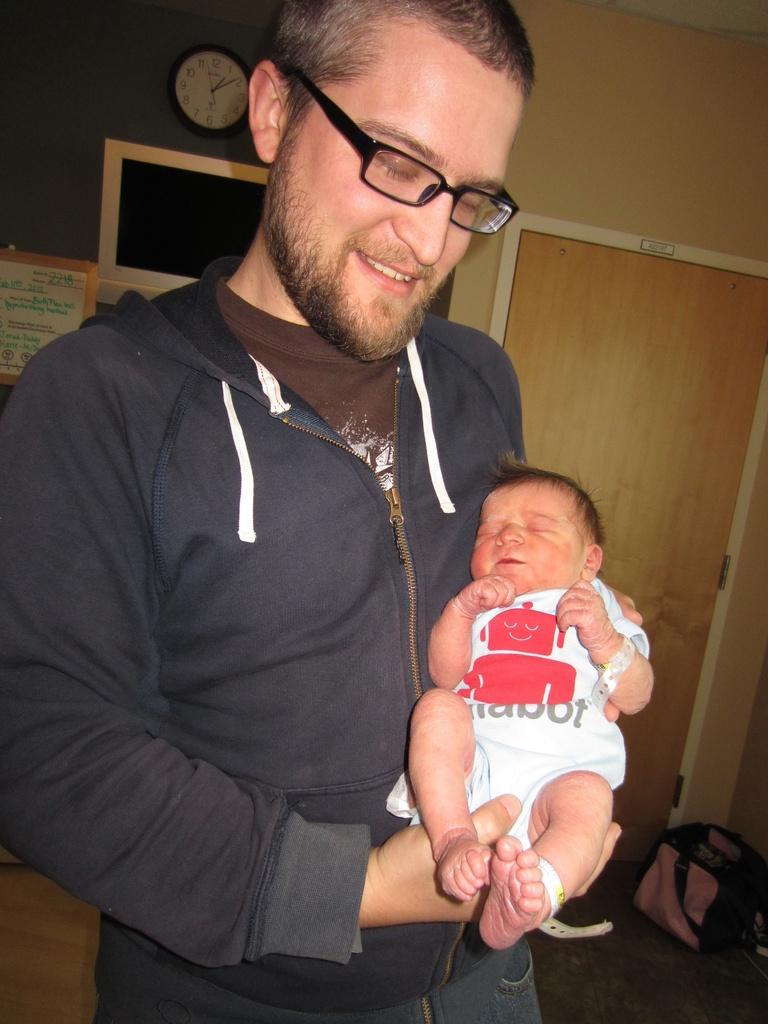Can you describe this image briefly? In the center of the image we can see one person is standing and he is holding one baby. And he is smiling and he is wearing glasses. In the background there is a wall, door, wall clock, banner, bag and a few other objects. On the banner, we can see some text. 